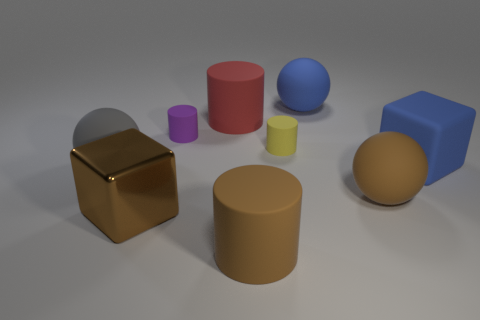Is there any other thing that is the same material as the large brown block?
Your answer should be compact. No. What is the size of the ball that is the same color as the rubber cube?
Your answer should be very brief. Large. There is a metal cube; are there any gray rubber spheres to the right of it?
Make the answer very short. No. Is the number of small yellow objects that are in front of the brown sphere greater than the number of brown matte things that are on the left side of the big blue matte sphere?
Your response must be concise. No. The blue object that is the same shape as the large gray object is what size?
Your response must be concise. Large. How many cylinders are big brown metallic things or gray things?
Make the answer very short. 0. There is a big cylinder that is the same color as the shiny thing; what material is it?
Keep it short and to the point. Rubber. Is the number of gray rubber things in front of the big brown ball less than the number of big matte balls to the left of the yellow rubber object?
Keep it short and to the point. Yes. How many objects are either tiny things behind the tiny yellow rubber object or large green cubes?
Provide a short and direct response. 1. What shape is the brown metal thing that is to the right of the big matte ball that is left of the big brown shiny thing?
Give a very brief answer. Cube. 